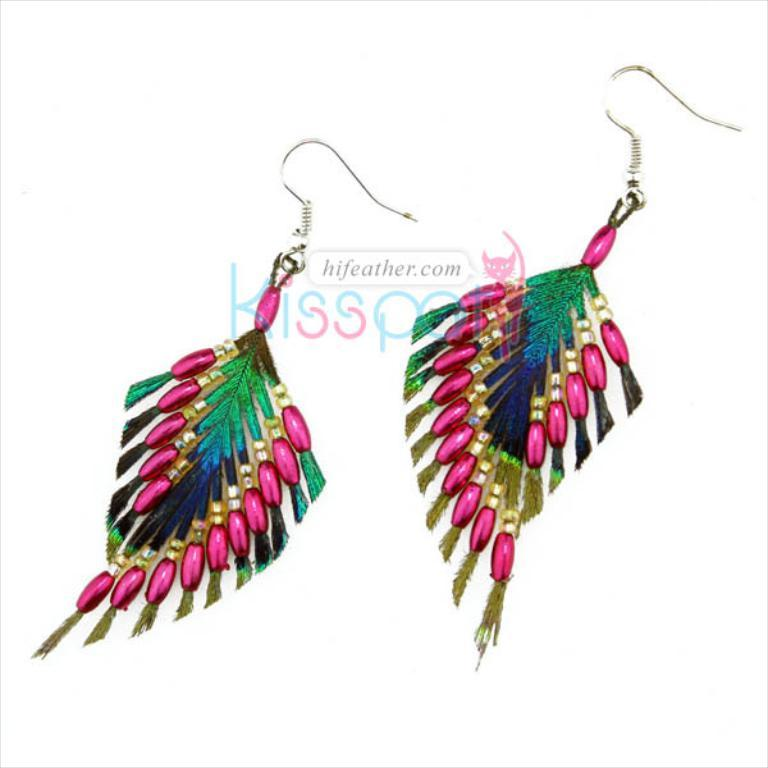What type of accessory is featured in the picture? There are earrings in the picture. What colors are the earrings? The earrings are in pink, green, and violet colors. Are there any words or symbols on the earrings? Yes, there is text at the back of the earrings. What is the color of the background in the image? The background of the image is white. What type of pail can be seen in the image? There is no pail present in the image; it features earrings in various colors with text on the back. How many circles are visible in the image? There is no specific mention of circles in the image, as it primarily focuses on the earrings and their features. 